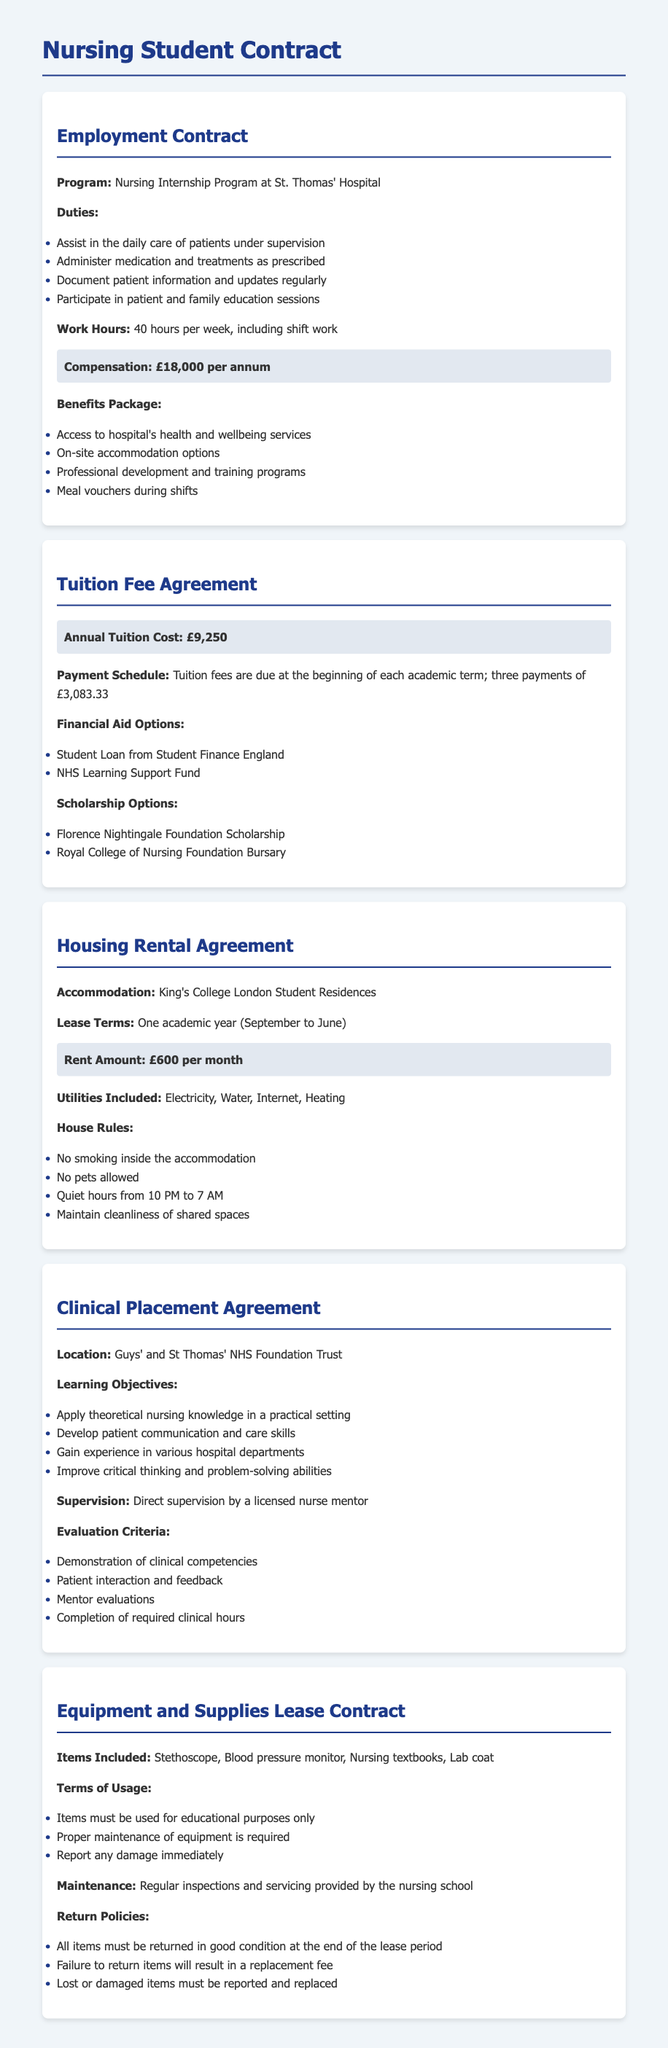What is the compensation for the nursing internship? The compensation is clearly stated in the Employment Contract section as £18,000 per annum.
Answer: £18,000 per annum What is the annual tuition cost? The annual tuition cost is specified in the Tuition Fee Agreement section as £9,250.
Answer: £9,250 What is the rent amount for student accommodation? The rent amount is detailed in the Housing Rental Agreement section as £600 per month.
Answer: £600 per month Where is the clinical placement located? The location of the clinical placement is mentioned in the Clinical Placement Agreement as Guys' and St Thomas' NHS Foundation Trust.
Answer: Guys' and St Thomas' NHS Foundation Trust What utilities are included in the housing rental? The utilities included are listed in the Housing Rental Agreement section as Electricity, Water, Internet, and Heating.
Answer: Electricity, Water, Internet, Heating How many hours per week are required for the internship? The required work hours per week are noted in the Employment Contract section as 40 hours per week.
Answer: 40 hours per week What items are included in the equipment and supplies lease? The items included in the lease are detailed in the Equipment and Supplies Lease Contract as Stethoscope, Blood pressure monitor, Nursing textbooks, Lab coat.
Answer: Stethoscope, Blood pressure monitor, Nursing textbooks, Lab coat What are the house rules regarding quiet hours? The house rules specify that quiet hours are from 10 PM to 7 AM.
Answer: 10 PM to 7 AM What financial aid options are available for tuition? The available financial aid options are listed as Student Loan from Student Finance England and NHS Learning Support Fund.
Answer: Student Loan from Student Finance England, NHS Learning Support Fund 